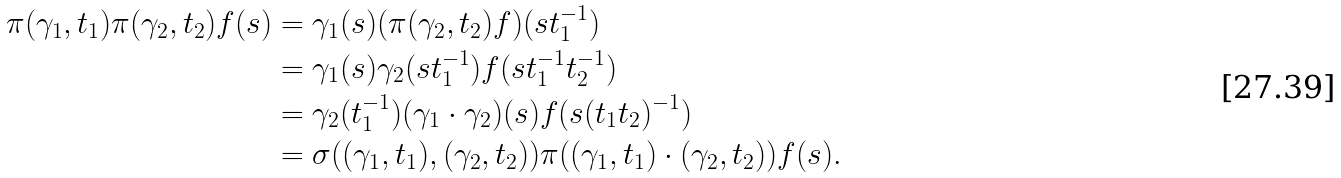<formula> <loc_0><loc_0><loc_500><loc_500>\pi ( \gamma _ { 1 } , t _ { 1 } ) \pi ( \gamma _ { 2 } , t _ { 2 } ) f ( s ) & = \gamma _ { 1 } ( s ) ( \pi ( \gamma _ { 2 } , t _ { 2 } ) f ) ( s t _ { 1 } ^ { - 1 } ) \\ & = \gamma _ { 1 } ( s ) \gamma _ { 2 } ( s t _ { 1 } ^ { - 1 } ) f ( s t _ { 1 } ^ { - 1 } t _ { 2 } ^ { - 1 } ) \\ & = \gamma _ { 2 } ( t _ { 1 } ^ { - 1 } ) ( \gamma _ { 1 } \cdot \gamma _ { 2 } ) ( s ) f ( s ( t _ { 1 } t _ { 2 } ) ^ { - 1 } ) \\ & = \sigma ( ( \gamma _ { 1 } , t _ { 1 } ) , ( \gamma _ { 2 } , t _ { 2 } ) ) \pi ( ( \gamma _ { 1 } , t _ { 1 } ) \cdot ( \gamma _ { 2 } , t _ { 2 } ) ) f ( s ) .</formula> 